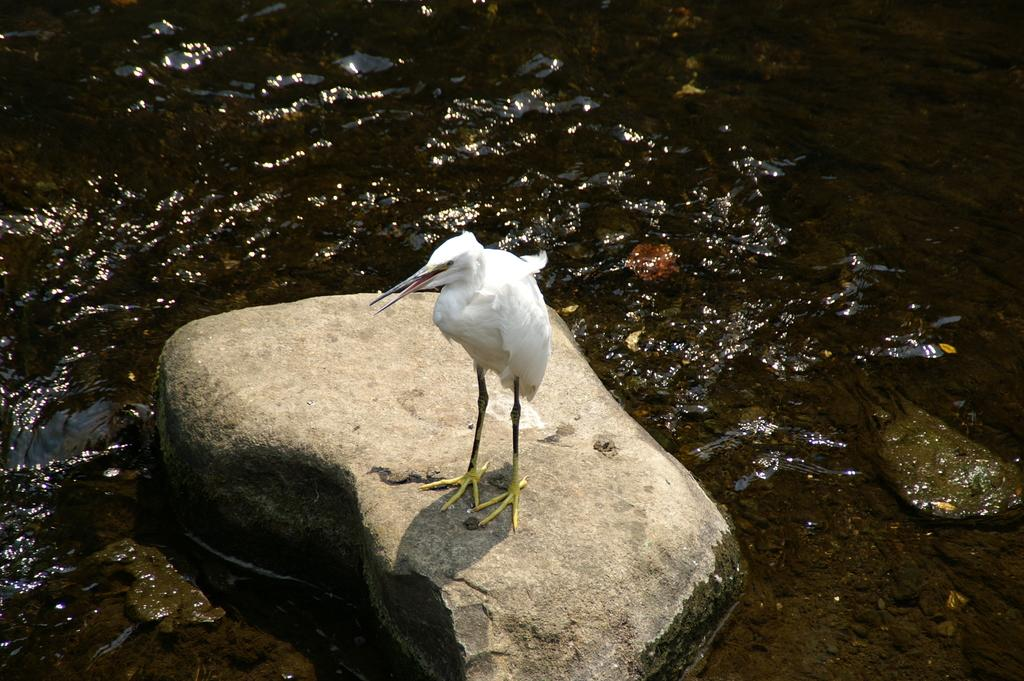What is the primary element visible in the image? There is water in the image. What other objects can be seen in the image? There is a rock and a white color crane in the image. How does the crane use its comb in the image? There is no comb present in the image, as the crane is a bird and not a person. 